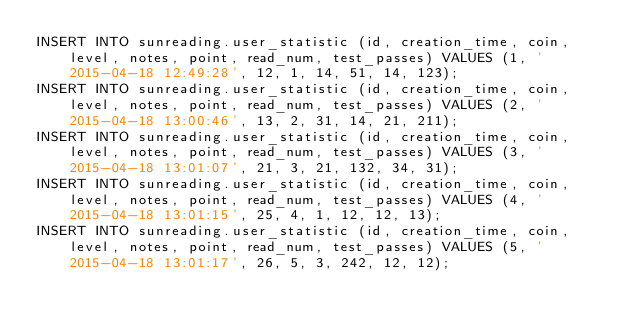Convert code to text. <code><loc_0><loc_0><loc_500><loc_500><_SQL_>INSERT INTO sunreading.user_statistic (id, creation_time, coin, level, notes, point, read_num, test_passes) VALUES (1, '2015-04-18 12:49:28', 12, 1, 14, 51, 14, 123);
INSERT INTO sunreading.user_statistic (id, creation_time, coin, level, notes, point, read_num, test_passes) VALUES (2, '2015-04-18 13:00:46', 13, 2, 31, 14, 21, 211);
INSERT INTO sunreading.user_statistic (id, creation_time, coin, level, notes, point, read_num, test_passes) VALUES (3, '2015-04-18 13:01:07', 21, 3, 21, 132, 34, 31);
INSERT INTO sunreading.user_statistic (id, creation_time, coin, level, notes, point, read_num, test_passes) VALUES (4, '2015-04-18 13:01:15', 25, 4, 1, 12, 12, 13);
INSERT INTO sunreading.user_statistic (id, creation_time, coin, level, notes, point, read_num, test_passes) VALUES (5, '2015-04-18 13:01:17', 26, 5, 3, 242, 12, 12);
</code> 